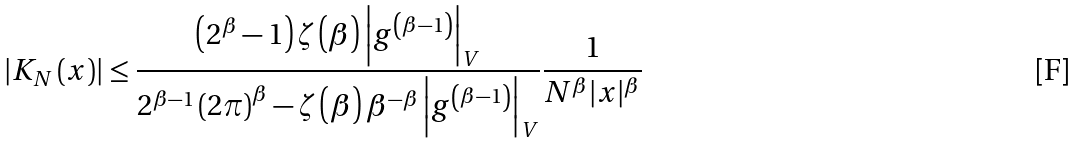Convert formula to latex. <formula><loc_0><loc_0><loc_500><loc_500>\left | K _ { N } \left ( x \right ) \right | \leq \frac { \left ( 2 ^ { \beta } - 1 \right ) \zeta \left ( \beta \right ) \left | g ^ { \left ( \beta - 1 \right ) } \right | _ { V } } { 2 ^ { \beta - 1 } \left ( 2 \pi \right ) ^ { \beta } - \zeta \left ( \beta \right ) \beta ^ { - \beta } \left | g ^ { \left ( \beta - 1 \right ) } \right | _ { V } } \frac { 1 } { N ^ { \beta } | x | ^ { \beta } }</formula> 